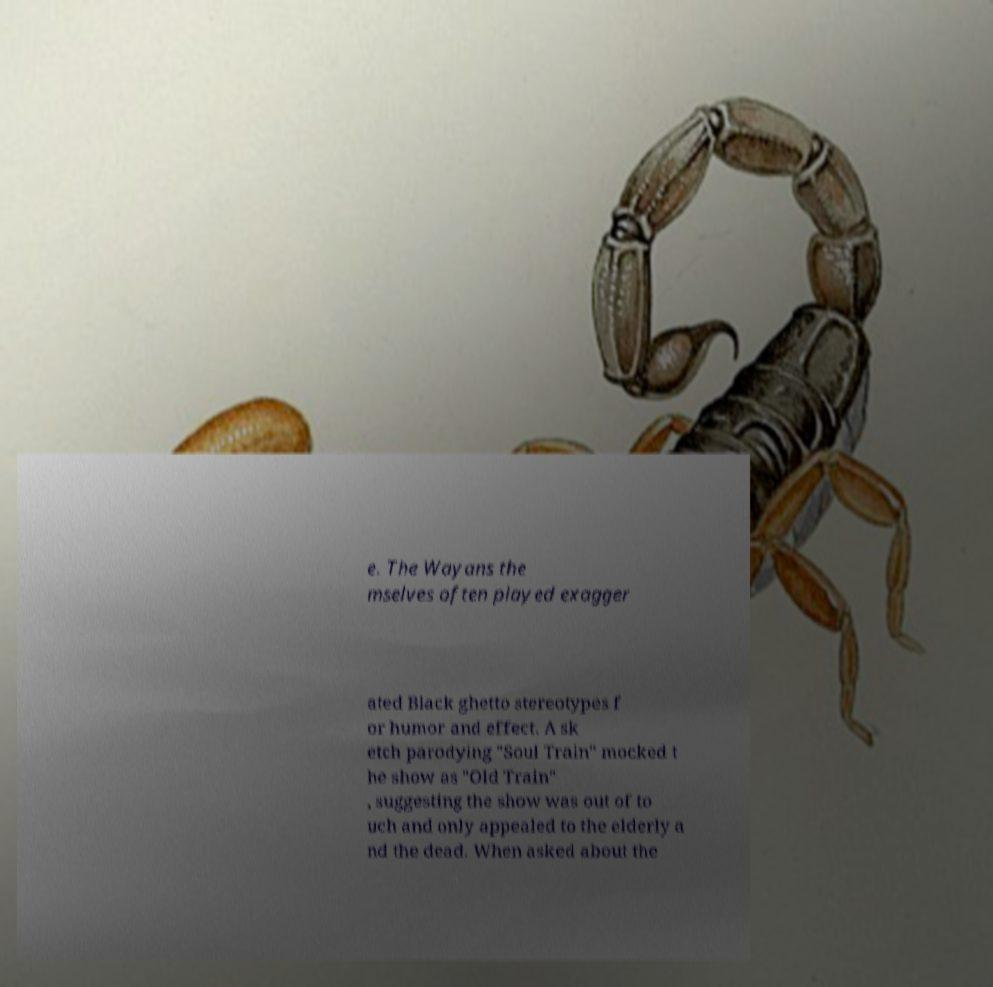Please read and relay the text visible in this image. What does it say? e. The Wayans the mselves often played exagger ated Black ghetto stereotypes f or humor and effect. A sk etch parodying "Soul Train" mocked t he show as "Old Train" , suggesting the show was out of to uch and only appealed to the elderly a nd the dead. When asked about the 